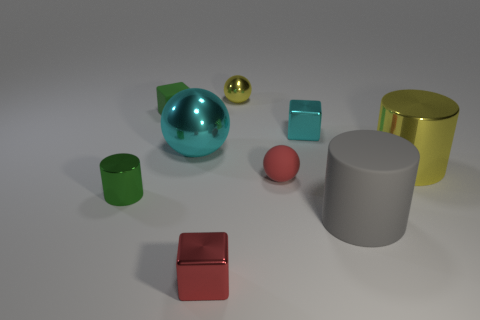What is the tiny ball that is in front of the cube behind the small cyan metallic object made of?
Give a very brief answer. Rubber. Is the small green matte thing the same shape as the red metallic thing?
Ensure brevity in your answer.  Yes. How many small metallic cubes are behind the red matte ball and in front of the small green shiny object?
Provide a short and direct response. 0. Are there an equal number of small metallic cubes that are in front of the tiny cyan cube and metal cylinders that are right of the big cyan shiny object?
Provide a short and direct response. Yes. There is a red object that is in front of the gray cylinder; is it the same size as the shiny cylinder right of the green cylinder?
Offer a terse response. No. The object that is both in front of the tiny green cylinder and left of the large gray object is made of what material?
Keep it short and to the point. Metal. Is the number of small green blocks less than the number of cyan shiny things?
Offer a very short reply. Yes. What is the size of the green object that is in front of the metal cylinder to the right of the tiny rubber cube?
Keep it short and to the point. Small. There is a big shiny object that is in front of the cyan metal object on the left side of the shiny sphere that is right of the large cyan metal object; what is its shape?
Ensure brevity in your answer.  Cylinder. There is a small sphere that is made of the same material as the tiny red cube; what color is it?
Offer a terse response. Yellow. 